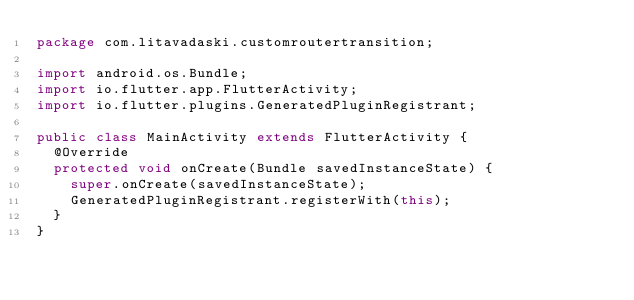Convert code to text. <code><loc_0><loc_0><loc_500><loc_500><_Java_>package com.litavadaski.customroutertransition;

import android.os.Bundle;
import io.flutter.app.FlutterActivity;
import io.flutter.plugins.GeneratedPluginRegistrant;

public class MainActivity extends FlutterActivity {
  @Override
  protected void onCreate(Bundle savedInstanceState) {
    super.onCreate(savedInstanceState);
    GeneratedPluginRegistrant.registerWith(this);
  }
}
</code> 